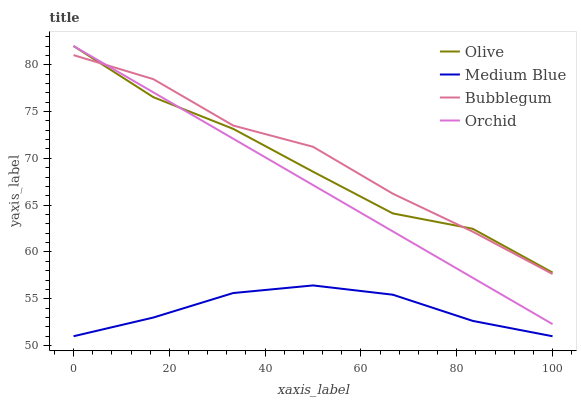Does Medium Blue have the minimum area under the curve?
Answer yes or no. Yes. Does Bubblegum have the maximum area under the curve?
Answer yes or no. Yes. Does Bubblegum have the minimum area under the curve?
Answer yes or no. No. Does Medium Blue have the maximum area under the curve?
Answer yes or no. No. Is Orchid the smoothest?
Answer yes or no. Yes. Is Olive the roughest?
Answer yes or no. Yes. Is Medium Blue the smoothest?
Answer yes or no. No. Is Medium Blue the roughest?
Answer yes or no. No. Does Medium Blue have the lowest value?
Answer yes or no. Yes. Does Bubblegum have the lowest value?
Answer yes or no. No. Does Orchid have the highest value?
Answer yes or no. Yes. Does Bubblegum have the highest value?
Answer yes or no. No. Is Medium Blue less than Orchid?
Answer yes or no. Yes. Is Orchid greater than Medium Blue?
Answer yes or no. Yes. Does Olive intersect Bubblegum?
Answer yes or no. Yes. Is Olive less than Bubblegum?
Answer yes or no. No. Is Olive greater than Bubblegum?
Answer yes or no. No. Does Medium Blue intersect Orchid?
Answer yes or no. No. 